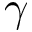<formula> <loc_0><loc_0><loc_500><loc_500>\gamma</formula> 